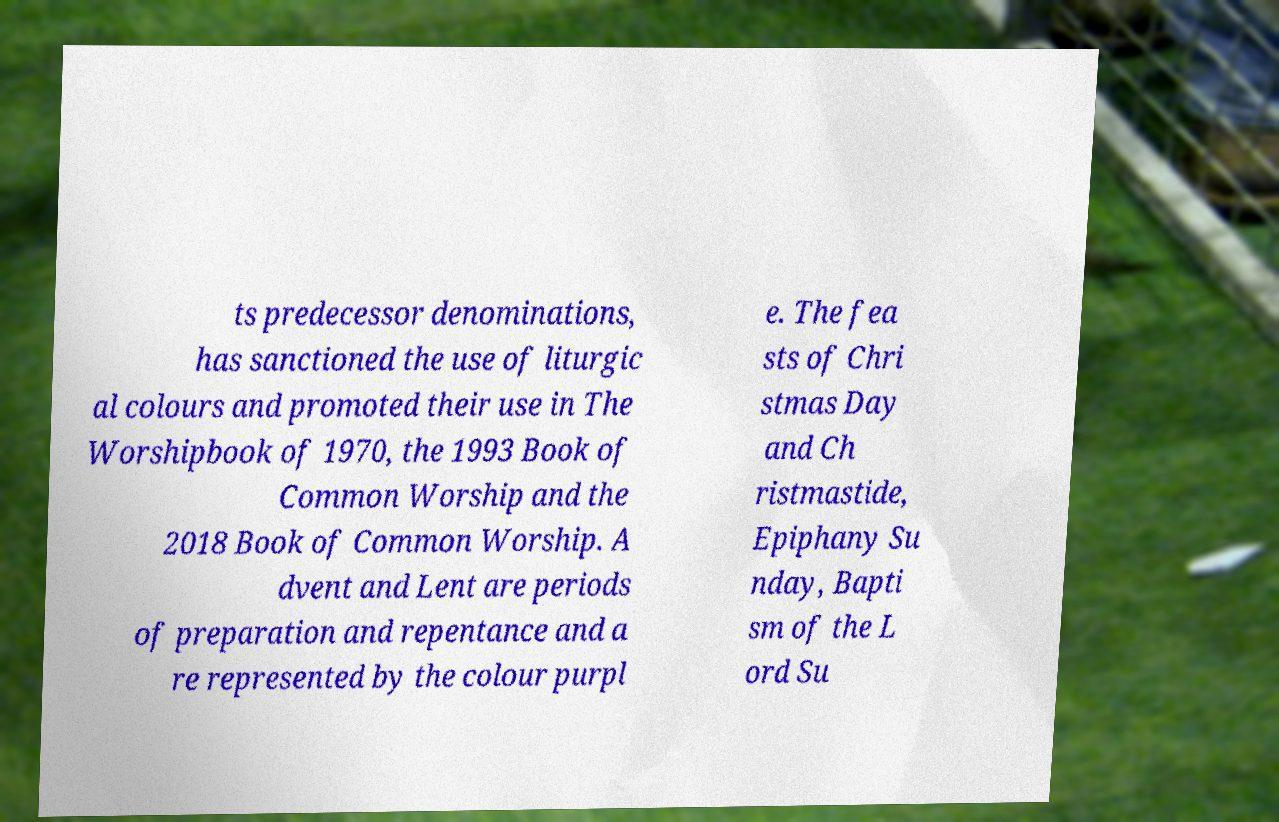Please identify and transcribe the text found in this image. ts predecessor denominations, has sanctioned the use of liturgic al colours and promoted their use in The Worshipbook of 1970, the 1993 Book of Common Worship and the 2018 Book of Common Worship. A dvent and Lent are periods of preparation and repentance and a re represented by the colour purpl e. The fea sts of Chri stmas Day and Ch ristmastide, Epiphany Su nday, Bapti sm of the L ord Su 